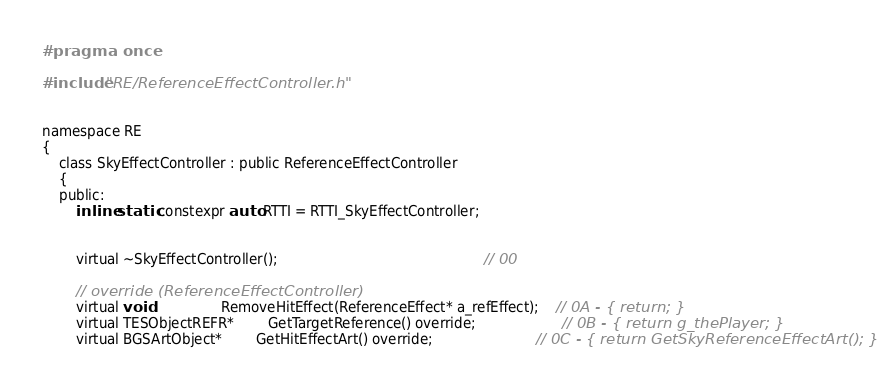<code> <loc_0><loc_0><loc_500><loc_500><_C_>#pragma once

#include "RE/ReferenceEffectController.h"


namespace RE
{
	class SkyEffectController : public ReferenceEffectController
	{
	public:
		inline static constexpr auto RTTI = RTTI_SkyEffectController;


		virtual ~SkyEffectController();												// 00

		// override (ReferenceEffectController)
		virtual void				RemoveHitEffect(ReferenceEffect* a_refEffect);	// 0A - { return; }
		virtual TESObjectREFR*		GetTargetReference() override;					// 0B - { return g_thePlayer; }
		virtual BGSArtObject*		GetHitEffectArt() override;						// 0C - { return GetSkyReferenceEffectArt(); }</code> 